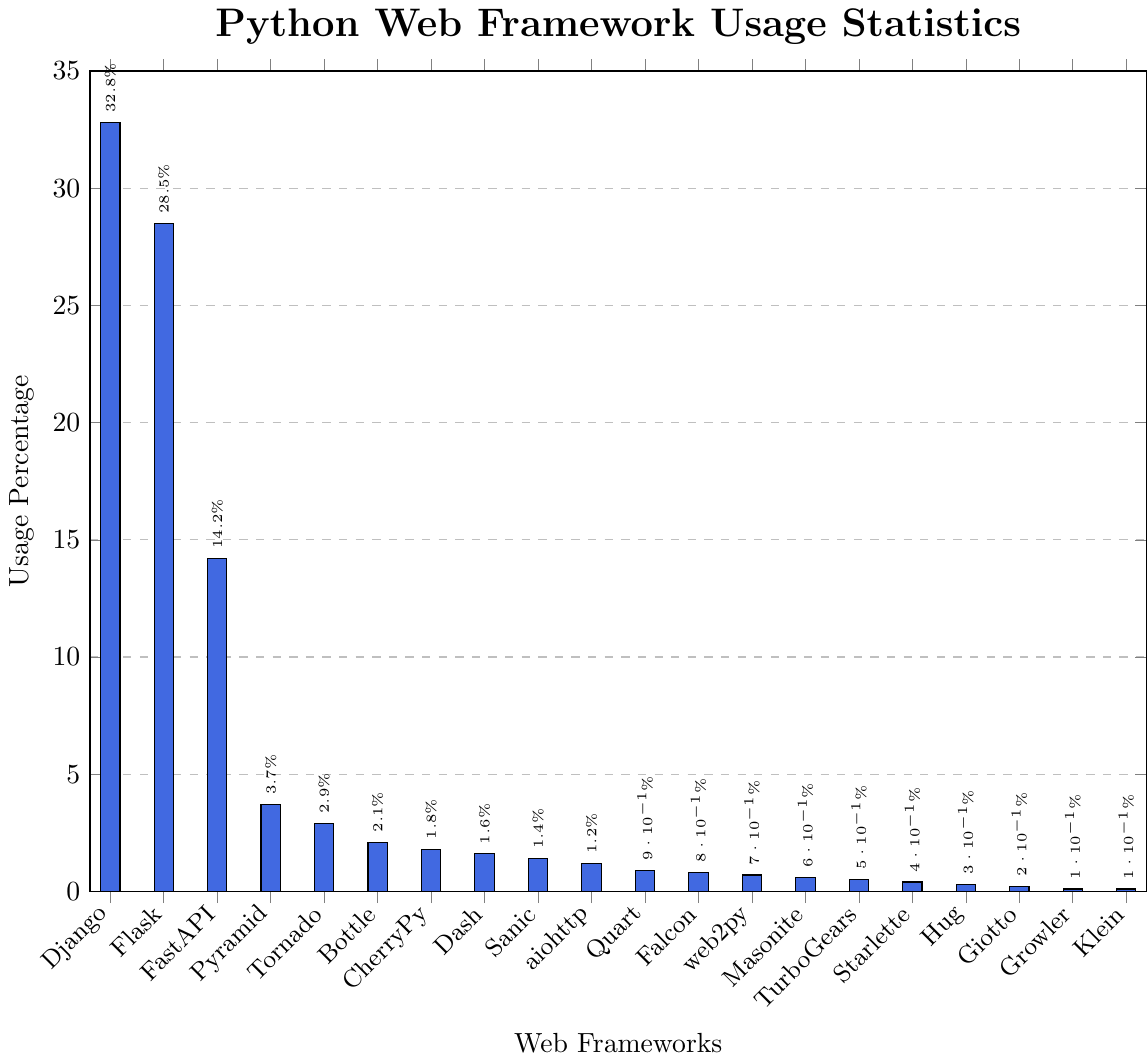What is the usage percentage of Django? The chart shows the usage percentage of different web frameworks, and the bar representing Django reaches up to 32.8%.
Answer: 32.8% Which web framework has the lowest usage percentage? By observing the chart, the shortest bars correspond to the frameworks with the lowest usage. Klein and Growler both have the smallest bars, each representing 0.1%.
Answer: Klein and Growler Which framework has a higher usage percentage, Flask or FastAPI? Comparing the heights of the bars for Flask and FastAPI, Flask has a bar that reaches 28.5% while FastAPI's bar reaches 14.2%. Therefore, Flask has a higher usage percentage than FastAPI.
Answer: Flask What is the combined usage percentage of Tornado, Bottle, and CherryPy? By adding the usage percentages of Tornado (2.9%), Bottle (2.1%), and CherryPy (1.8%), we get 2.9 + 2.1 + 1.8 = 6.8%.
Answer: 6.8% How many frameworks have a usage percentage of less than 1.0%? Counting the bars that do not reach 1.0% on the y-axis: Falcon (0.8%), web2py (0.7%), Masonite (0.6%), TurboGears (0.5%), Starlette (0.4%), Hug (0.3%), Giotto (0.2%), Growler (0.1%), and Klein (0.1%), there are 9 frameworks.
Answer: 9 Which framework shows the closest usage percentage to the average percentage of all listed frameworks? To find the average percentage: Sum all usage percentages (32.8 + 28.5 + 14.2 + 3.7 + 2.9 + 2.1 + 1.8 + 1.6 + 1.4 + 1.2 + 0.9 + 0.8 + 0.7 + 0.6 + 0.5 + 0.4 + 0.3 + 0.2 + 0.1 + 0.1 = 98.6) and divide by 20 frameworks: 98.6 / 20 = 4.93%. FastAPI, with 14.2%, is the closest to this averaged value, but notably higher. Thus, frameworks close to 4.93% are rare in this set, but Pyramid (3.7%) is the closest.
Answer: Pyramid What is the difference in usage percentage between Dash and Quart? Dash has a usage percentage of 1.6%, and Quart has a usage percentage of 0.9%. The difference is 1.6 - 0.9 = 0.7%.
Answer: 0.7% Which web frameworks fall under the 2.0% usage percentage mark? Reading the bars below the 2.0% mark on the y-axis: CherryPy (1.8%), Dash (1.6%), Sanic (1.4%), aiohttp (1.2%), Quart (0.9%), Falcon (0.8%), web2py (0.7%), Masonite (0.6%), TurboGears (0.5%), Starlette (0.4%), Hug (0.3%), Giotto (0.2%), Growler (0.1%), and Klein (0.1%).
Answer: CherryPy, Dash, Sanic, aiohttp, Quart, Falcon, web2py, Masonite, TurboGears, Starlette, Hug, Giotto, Growler, Klein 